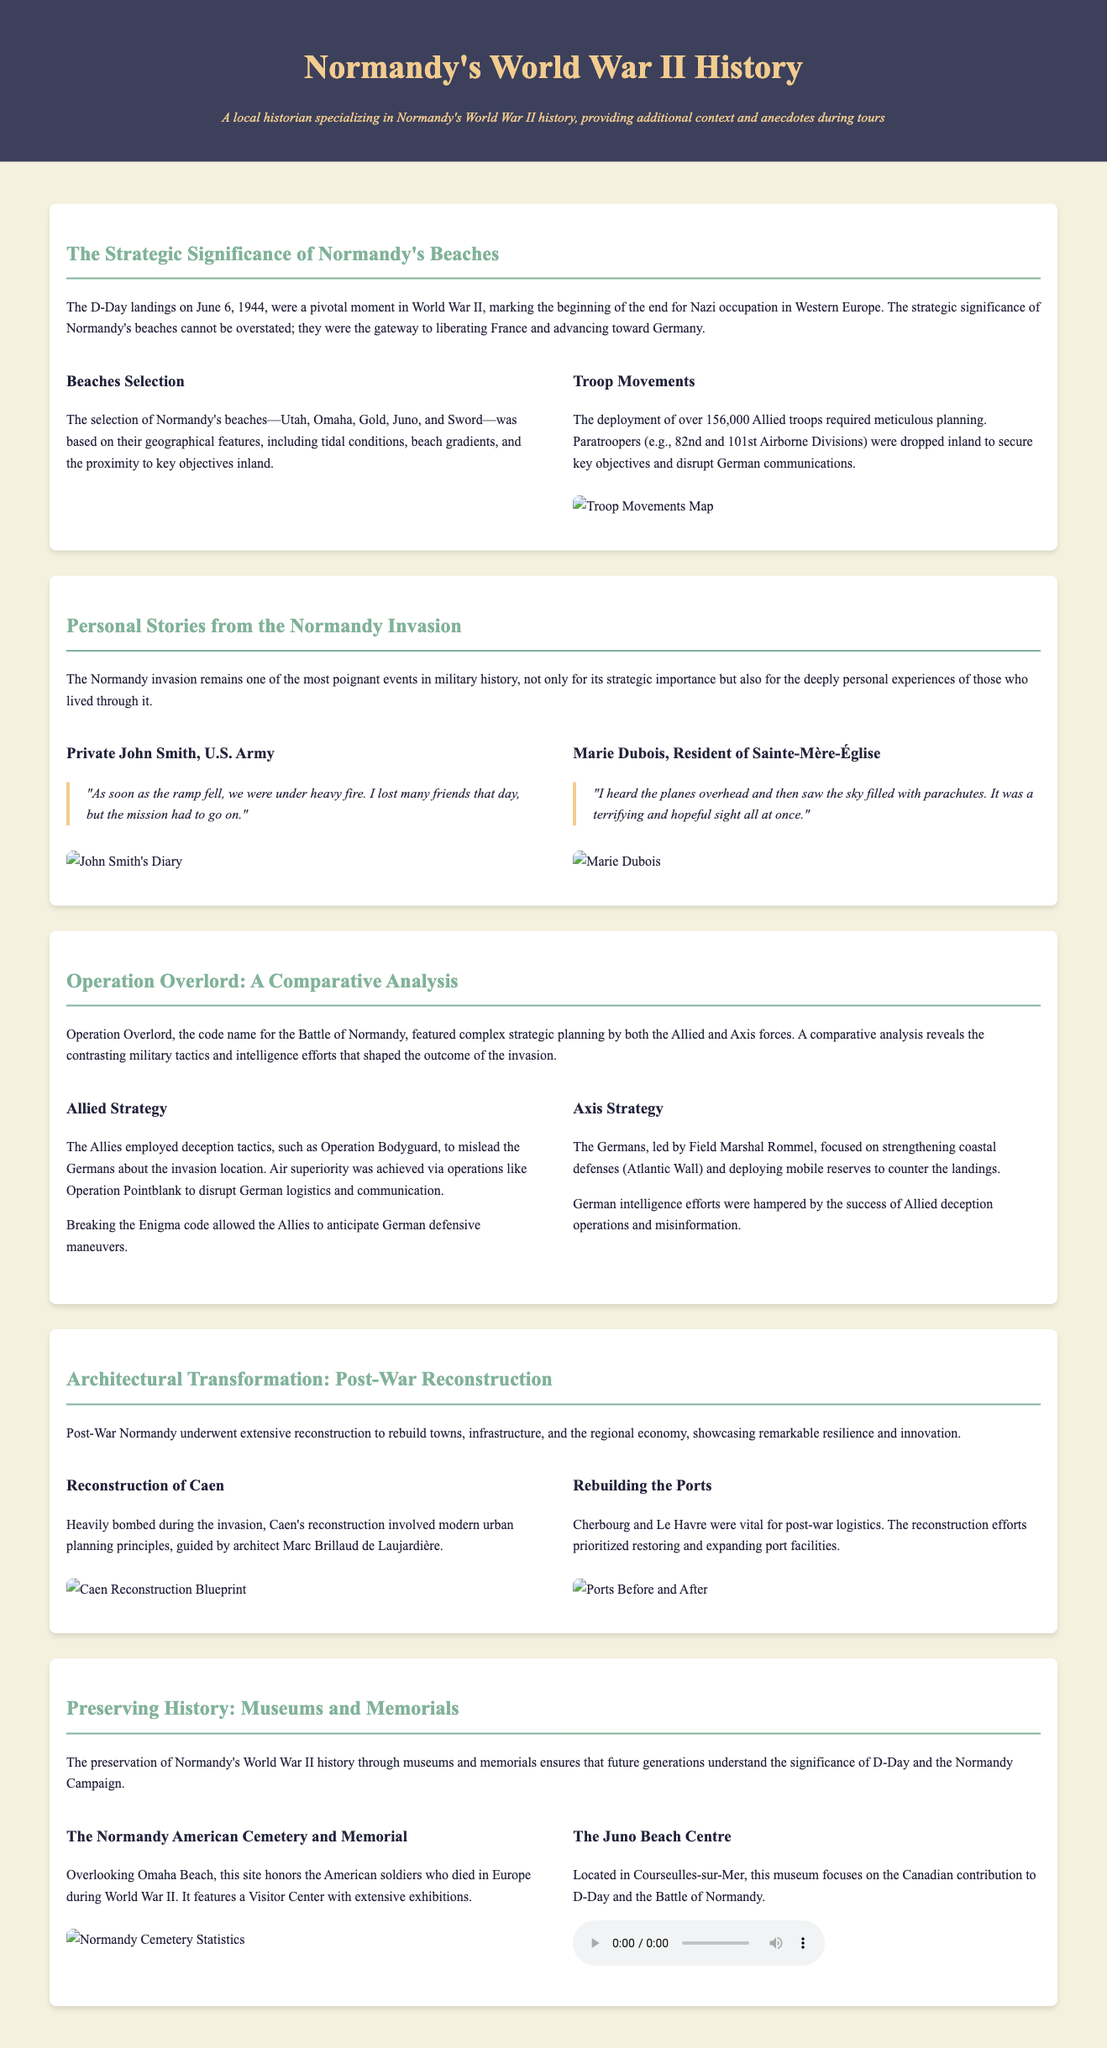What were the names of the beaches selected for D-Day? The document lists Utah, Omaha, Gold, Juno, and Sword as the selected beaches for the D-Day landings.
Answer: Utah, Omaha, Gold, Juno, Sword Who wrote a diary captured in the personal stories section? The document mentions Private John Smith as a featured individual whose diary is included in the personal stories section.
Answer: Private John Smith What was the total number of Allied troops deployed on D-Day? The document states that over 156,000 Allied troops were deployed during the D-Day landings.
Answer: Over 156,000 Which German military leader was mentioned as focusing on coastal defenses? The document identifies Field Marshal Rommel as the German leader focused on strengthening coastal defenses.
Answer: Field Marshal Rommel What was the main focus of the Juno Beach Centre? The document indicates that the Juno Beach Centre focuses on the Canadian contribution to D-Day and the Battle of Normandy.
Answer: Canadian contribution What strategy did the Allies use to mislead German forces? The document describes Operation Bodyguard as a deception tactic used by the Allies to mislead German forces about the invasion.
Answer: Operation Bodyguard In which town was reconstruction guided by architect Marc Brillaud de Laujardière? According to the document, the reconstruction of Caen was guided by architect Marc Brillaud de Laujardière.
Answer: Caen What site honors American soldiers who died during World War II? The document states that the Normandy American Cemetery and Memorial honors American soldiers who died in Europe during World War II.
Answer: Normandy American Cemetery and Memorial 